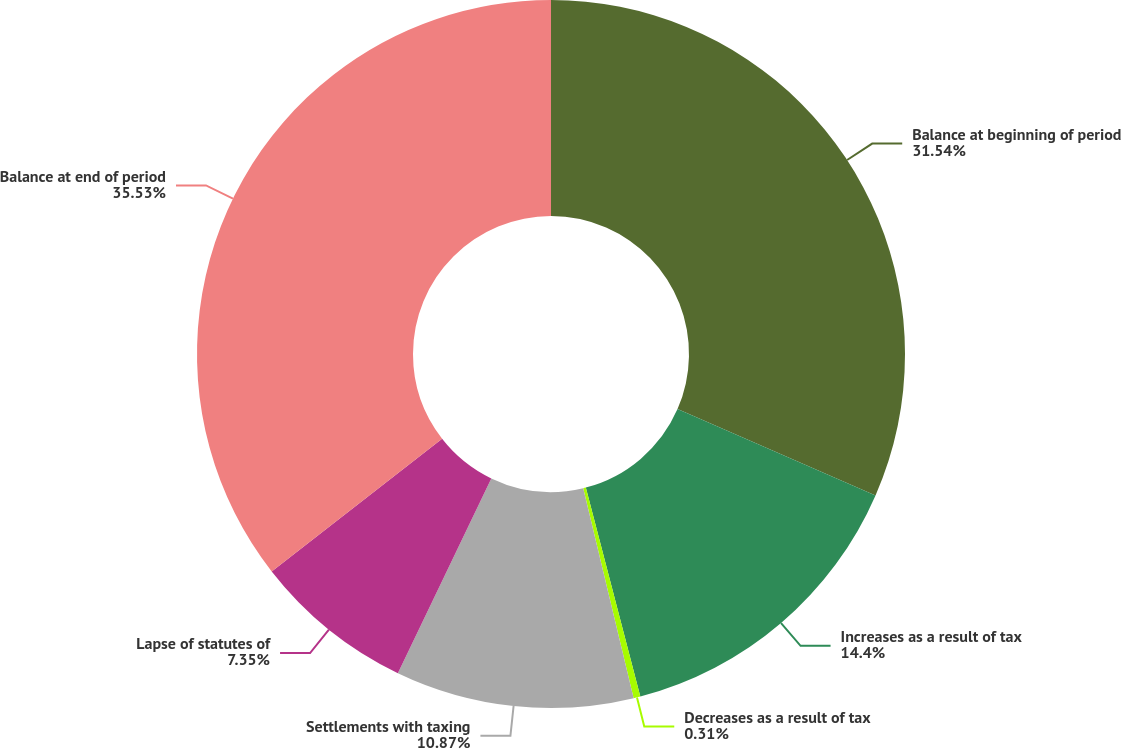Convert chart. <chart><loc_0><loc_0><loc_500><loc_500><pie_chart><fcel>Balance at beginning of period<fcel>Increases as a result of tax<fcel>Decreases as a result of tax<fcel>Settlements with taxing<fcel>Lapse of statutes of<fcel>Balance at end of period<nl><fcel>31.54%<fcel>14.4%<fcel>0.31%<fcel>10.87%<fcel>7.35%<fcel>35.53%<nl></chart> 